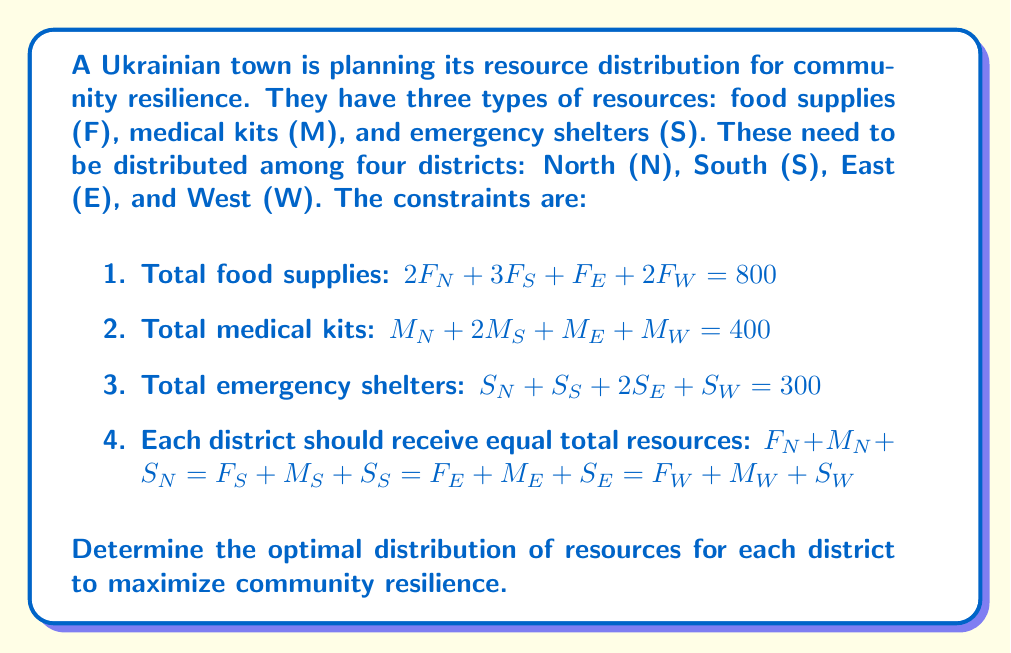Show me your answer to this math problem. To solve this problem, we need to set up a system of linear equations based on the given constraints and solve them simultaneously. Let's approach this step-by-step:

1) First, let's define our variables:
   $F_N, F_S, F_E, F_W$ for food supplies
   $M_N, M_S, M_E, M_W$ for medical kits
   $S_N, S_S, S_E, S_W$ for emergency shelters

2) We have the following equations from the constraints:

   $2F_N + 3F_S + F_E + 2F_W = 800$ ... (1)
   $M_N + 2M_S + M_E + M_W = 400$ ... (2)
   $S_N + S_S + 2S_E + S_W = 300$ ... (3)

3) From the equal distribution constraint:

   $F_N + M_N + S_N = F_S + M_S + S_S = F_E + M_E + S_E = F_W + M_W + S_W$ ... (4)

   Let's call this sum $x$. So we have:

   $F_N + M_N + S_N = x$
   $F_S + M_S + S_S = x$
   $F_E + M_E + S_E = x$
   $F_W + M_W + S_W = x$

4) Adding these four equations:

   $(F_N + F_S + F_E + F_W) + (M_N + M_S + M_E + M_W) + (S_N + S_S + S_E + S_W) = 4x$

5) From equations (1), (2), and (3), we know:

   $\frac{800}{2} + 400 + 300 = 4x$

   $1100 = 4x$
   $x = 275$

6) Now we know that each district should receive resources totaling 275.

7) Using this information with equations (1), (2), and (3):

   $2F_N + 3F_S + F_E + 2F_W = 800$
   $F_N + 2F_S + F_E + F_W = 600$
   $F_N + F_S + 2F_E + F_W = 600$
   $F_N + F_S + F_E + F_W = 500$

8) Solving this system of equations:

   $F_N = 100, F_S = 200, F_E = 100, F_W = 100$

9) Similarly for medical kits:

   $M_N = 100, M_S = 50, M_E = 150, M_W = 100$

10) And for shelters:

    $S_N = 75, S_S = 25, S_E = 125, S_W = 75$

11) We can verify that these solutions satisfy all constraints, including the equal distribution constraint (each district's total = 275).
Answer: The optimal distribution of resources for each district is:

North: 100 food supplies, 100 medical kits, 75 emergency shelters
South: 200 food supplies, 50 medical kits, 25 emergency shelters
East: 100 food supplies, 150 medical kits, 125 emergency shelters
West: 100 food supplies, 100 medical kits, 75 emergency shelters 